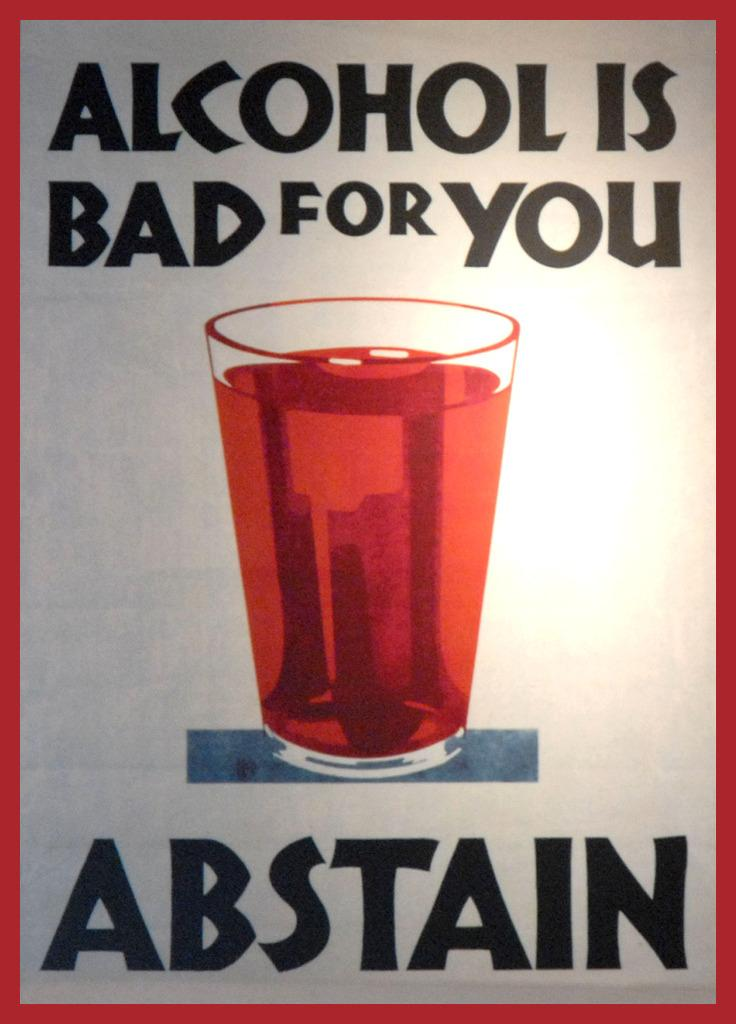<image>
Create a compact narrative representing the image presented. A sign or poster encouraging abstinence from consuming alcohol. 